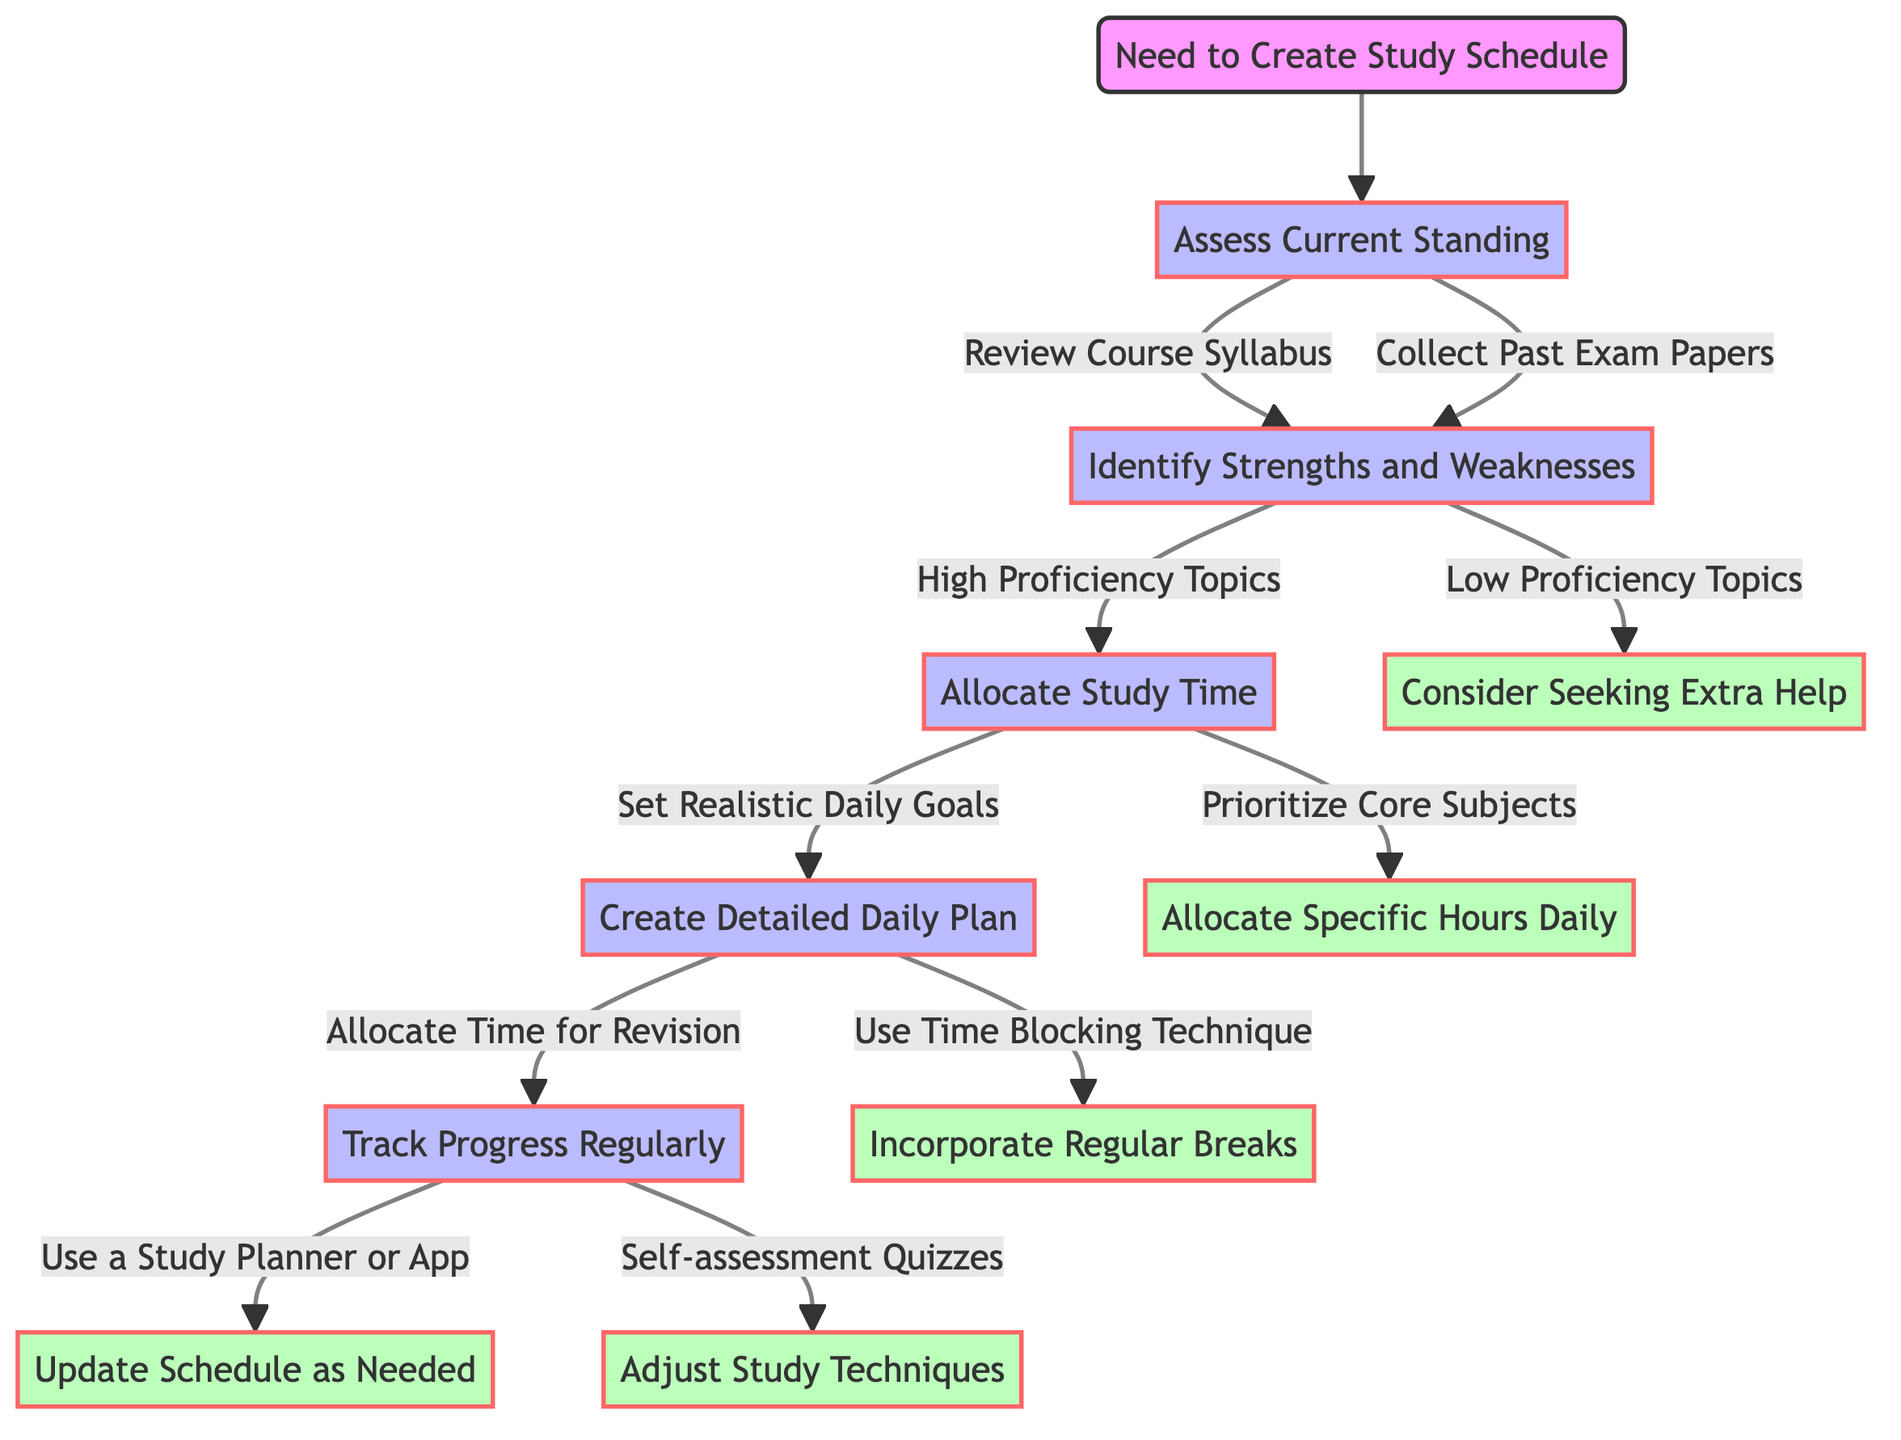What is the first decision in the diagram? The first decision is to "Assess Current Standing," which follows the initial step of needing to create a study schedule.
Answer: Assess Current Standing How many actions are associated with "Assess Current Standing"? There are two actions associated with "Assess Current Standing": "Review Course Syllabus" and "Collect Past Exam Papers."
Answer: 2 What follows after identifying strengths and weaknesses if there are low proficiency topics? If there are low proficiency topics, the next step is "Consider Seeking Extra Help."
Answer: Consider Seeking Extra Help Which decision leads to creating a detailed daily plan? The decision that leads to creating a detailed daily plan is "Set Realistic Daily Goals."
Answer: Set Realistic Daily Goals What type of technique is recommended in the "Create Detailed Daily Plan"? The recommended technique is the "Time Blocking Technique."
Answer: Time Blocking Technique What two actions are suggested under "Track Progress Regularly"? The two suggested actions are "Use a Study Planner or App" and "Self-assessment Quizzes."
Answer: Use a Study Planner or App, Self-assessment Quizzes Which node is the last step before updating the schedule? The last step before updating the schedule is "Use a Study Planner or App."
Answer: Use a Study Planner or App What happens after setting realistic daily goals? After setting realistic daily goals, it leads to "Create Detailed Daily Plan."
Answer: Create Detailed Daily Plan What is the relationship between "Identify Strengths and Weaknesses" and "Allocate Study Time"? "Identify Strengths and Weaknesses" leads to "Allocate Study Time", indicating that assessing proficiency levels informs how study time is allocated.
Answer: Lead to 